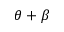<formula> <loc_0><loc_0><loc_500><loc_500>\theta + \beta</formula> 